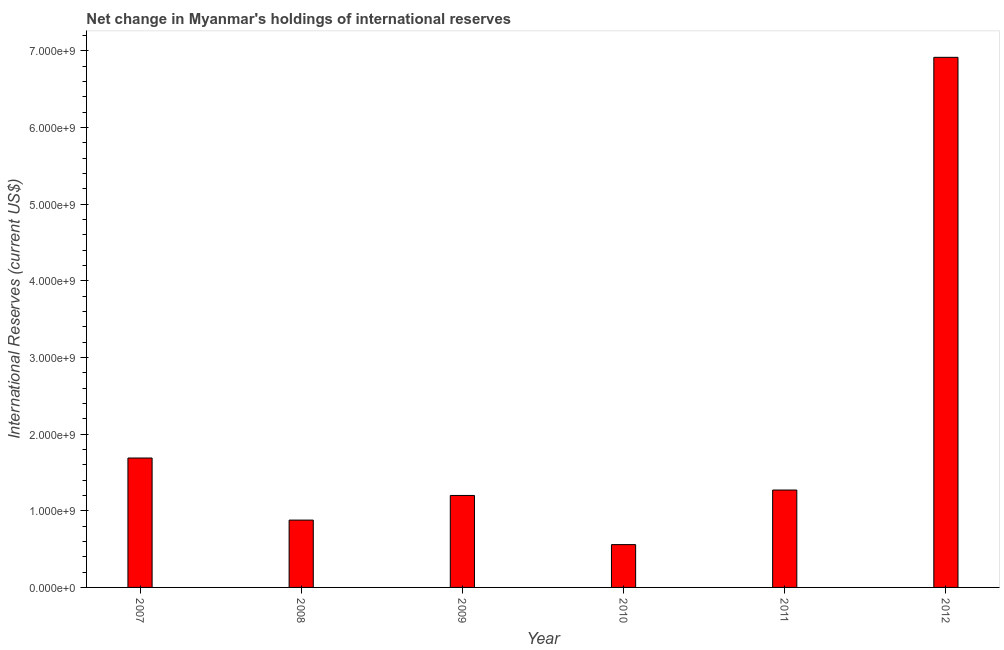What is the title of the graph?
Your answer should be very brief. Net change in Myanmar's holdings of international reserves. What is the label or title of the Y-axis?
Keep it short and to the point. International Reserves (current US$). What is the reserves and related items in 2007?
Your answer should be very brief. 1.69e+09. Across all years, what is the maximum reserves and related items?
Offer a very short reply. 6.92e+09. Across all years, what is the minimum reserves and related items?
Keep it short and to the point. 5.59e+08. What is the sum of the reserves and related items?
Your answer should be compact. 1.25e+1. What is the difference between the reserves and related items in 2009 and 2011?
Provide a succinct answer. -7.08e+07. What is the average reserves and related items per year?
Offer a terse response. 2.09e+09. What is the median reserves and related items?
Ensure brevity in your answer.  1.24e+09. In how many years, is the reserves and related items greater than 6400000000 US$?
Your answer should be compact. 1. What is the ratio of the reserves and related items in 2007 to that in 2011?
Give a very brief answer. 1.33. What is the difference between the highest and the second highest reserves and related items?
Keep it short and to the point. 5.23e+09. Is the sum of the reserves and related items in 2011 and 2012 greater than the maximum reserves and related items across all years?
Keep it short and to the point. Yes. What is the difference between the highest and the lowest reserves and related items?
Provide a short and direct response. 6.36e+09. How many bars are there?
Provide a short and direct response. 6. What is the International Reserves (current US$) in 2007?
Your answer should be compact. 1.69e+09. What is the International Reserves (current US$) of 2008?
Provide a succinct answer. 8.78e+08. What is the International Reserves (current US$) of 2009?
Provide a succinct answer. 1.20e+09. What is the International Reserves (current US$) of 2010?
Provide a succinct answer. 5.59e+08. What is the International Reserves (current US$) of 2011?
Keep it short and to the point. 1.27e+09. What is the International Reserves (current US$) of 2012?
Offer a terse response. 6.92e+09. What is the difference between the International Reserves (current US$) in 2007 and 2008?
Your response must be concise. 8.10e+08. What is the difference between the International Reserves (current US$) in 2007 and 2009?
Your answer should be compact. 4.88e+08. What is the difference between the International Reserves (current US$) in 2007 and 2010?
Keep it short and to the point. 1.13e+09. What is the difference between the International Reserves (current US$) in 2007 and 2011?
Make the answer very short. 4.18e+08. What is the difference between the International Reserves (current US$) in 2007 and 2012?
Your response must be concise. -5.23e+09. What is the difference between the International Reserves (current US$) in 2008 and 2009?
Offer a very short reply. -3.21e+08. What is the difference between the International Reserves (current US$) in 2008 and 2010?
Provide a short and direct response. 3.20e+08. What is the difference between the International Reserves (current US$) in 2008 and 2011?
Your answer should be compact. -3.92e+08. What is the difference between the International Reserves (current US$) in 2008 and 2012?
Your response must be concise. -6.04e+09. What is the difference between the International Reserves (current US$) in 2009 and 2010?
Your answer should be very brief. 6.41e+08. What is the difference between the International Reserves (current US$) in 2009 and 2011?
Offer a very short reply. -7.08e+07. What is the difference between the International Reserves (current US$) in 2009 and 2012?
Your answer should be very brief. -5.72e+09. What is the difference between the International Reserves (current US$) in 2010 and 2011?
Your answer should be very brief. -7.12e+08. What is the difference between the International Reserves (current US$) in 2010 and 2012?
Make the answer very short. -6.36e+09. What is the difference between the International Reserves (current US$) in 2011 and 2012?
Offer a very short reply. -5.65e+09. What is the ratio of the International Reserves (current US$) in 2007 to that in 2008?
Keep it short and to the point. 1.92. What is the ratio of the International Reserves (current US$) in 2007 to that in 2009?
Provide a succinct answer. 1.41. What is the ratio of the International Reserves (current US$) in 2007 to that in 2010?
Offer a very short reply. 3.02. What is the ratio of the International Reserves (current US$) in 2007 to that in 2011?
Offer a very short reply. 1.33. What is the ratio of the International Reserves (current US$) in 2007 to that in 2012?
Offer a terse response. 0.24. What is the ratio of the International Reserves (current US$) in 2008 to that in 2009?
Your response must be concise. 0.73. What is the ratio of the International Reserves (current US$) in 2008 to that in 2010?
Provide a short and direct response. 1.57. What is the ratio of the International Reserves (current US$) in 2008 to that in 2011?
Keep it short and to the point. 0.69. What is the ratio of the International Reserves (current US$) in 2008 to that in 2012?
Provide a succinct answer. 0.13. What is the ratio of the International Reserves (current US$) in 2009 to that in 2010?
Your response must be concise. 2.15. What is the ratio of the International Reserves (current US$) in 2009 to that in 2011?
Ensure brevity in your answer.  0.94. What is the ratio of the International Reserves (current US$) in 2009 to that in 2012?
Provide a short and direct response. 0.17. What is the ratio of the International Reserves (current US$) in 2010 to that in 2011?
Offer a terse response. 0.44. What is the ratio of the International Reserves (current US$) in 2010 to that in 2012?
Keep it short and to the point. 0.08. What is the ratio of the International Reserves (current US$) in 2011 to that in 2012?
Offer a very short reply. 0.18. 